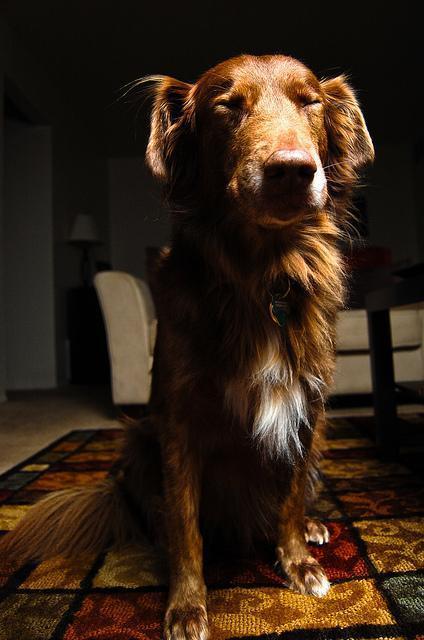How many couches are there?
Give a very brief answer. 1. 